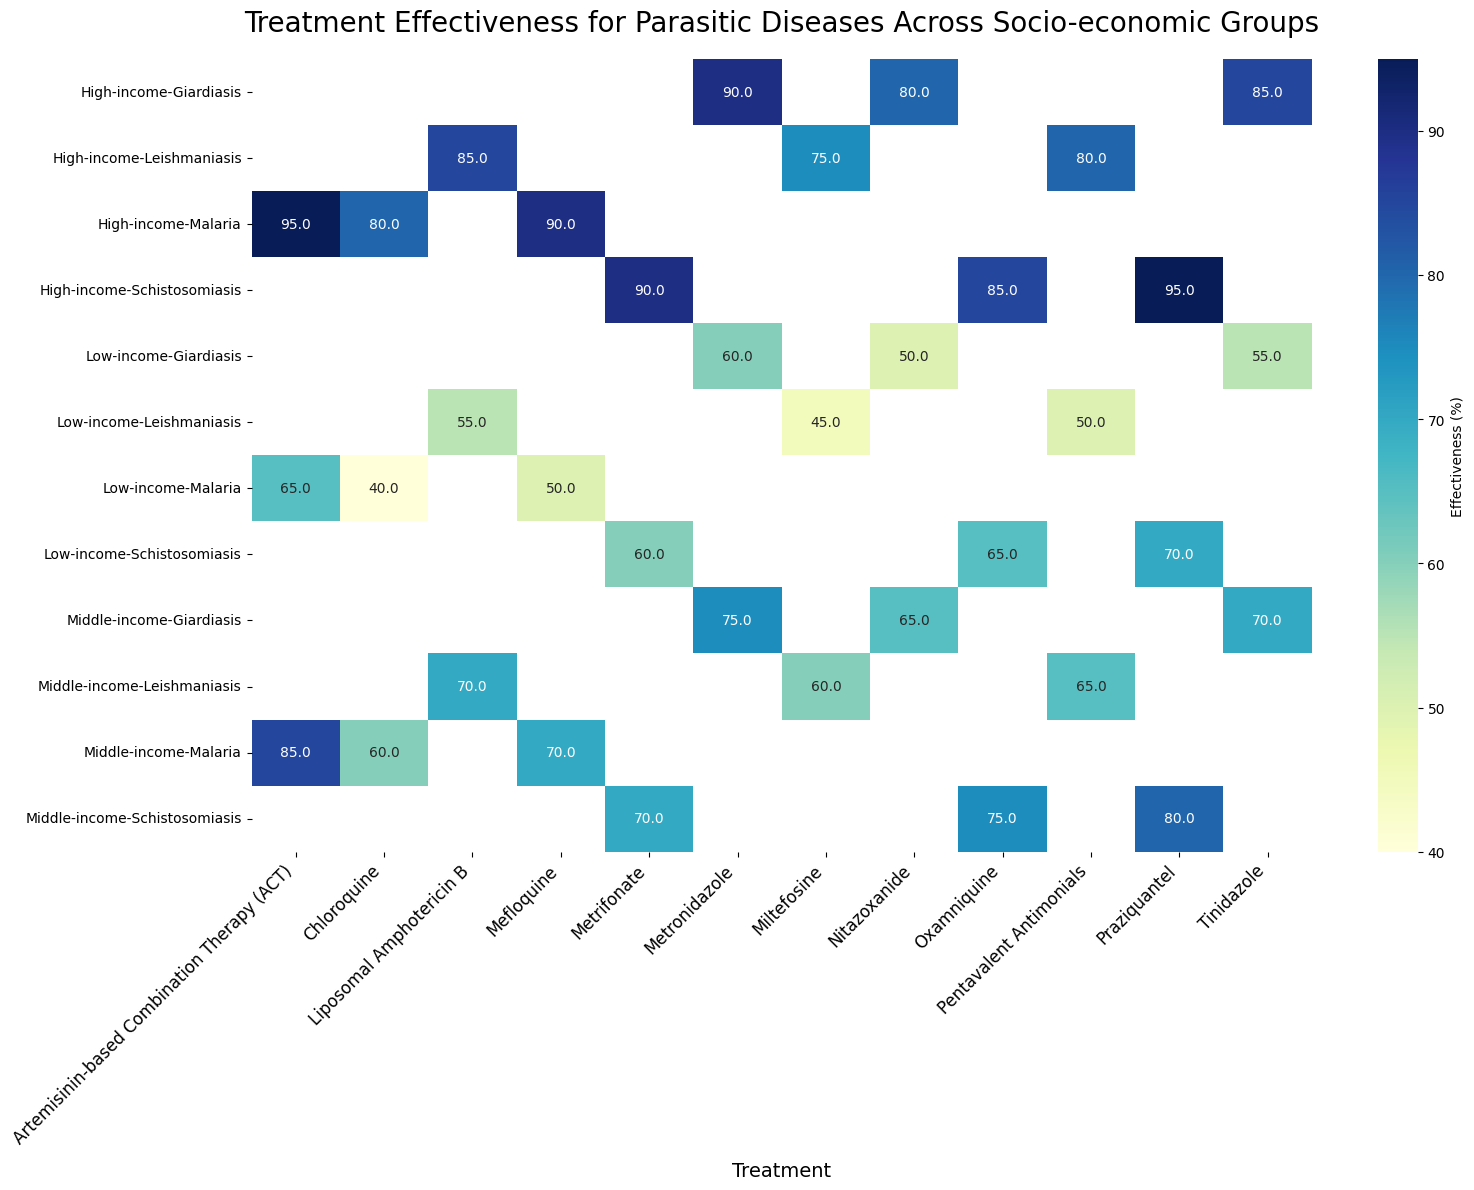Which socio-economic group has the highest treatment effectiveness for Malaria with Artemisinin-based Combination Therapy (ACT)? To find this, locate the rows for each socio-economic group under Malaria and identify the values for Artemisinin-based Combination Therapy (ACT). Compare the values 65%, 85%, and 95%. The highest value is 95% for the High-income group.
Answer: High-income Which treatment shows the least effectiveness for Giardiasis in Low-income groups? Look at the Giardiasis row under the Low-income socio-economic group, and compare the effectiveness values of the treatments: Metronidazole (60%), Tinidazole (55%), and Nitazoxanide (50%). The least effective treatment is Nitazoxanide (50%).
Answer: Nitazoxanide What is the average effectiveness of Praziquantel for treating Schistosomiasis across all socio-economic groups? Identify the effectiveness values for Praziquantel in each socio-economic group: 70% (Low-income), 80% (Middle-income), and 95% (High-income). Calculate the average: (70 + 80 + 95) / 3 = 81.67%.
Answer: 81.67% Which treatment for Leishmaniasis has the smallest range of effectiveness between the socio-economic groups? Find the effectiveness for each treatment across the socio-economic groups: Liposomal Amphotericin B (55%, 70%, 85%), Pentavalent Antimonials (50%, 65%, 80%), Miltefosine (45%, 60%, 75%). Calculate the range (max - min) for each treatment: Liposomal Amphotericin B (85 - 55 = 30), Pentavalent Antimonials (80 - 50 = 30), Miltefosine (75 - 45 = 30). All treatments have the same range (30).
Answer: All treatments have the same range (30) Between Chloroquine and Artemisinin-based Combination Therapy (ACT) for Malaria, which treatment shows greater improvement in effectiveness when comparing Low-income to High-income groups? Calculate the difference in effectiveness between Low-income and High-income for both treatments: Chloroquine (80 - 40 = 40), Artemisinin-based Combination Therapy (ACT) (95 - 65 = 30). Chloroquine shows a greater improvement.
Answer: Chloroquine How does treatment effectiveness for Mefloquine in High-income groups compare to the overall effectiveness of Mefloquine across all socio-economic groups for Malaria? Identify effectiveness values for Mefloquine in each socio-economic group: 50% (Low-income), 70% (Middle-income), 90% (High-income). Calculate the overall effectiveness: (50 + 70 + 90) / 3 = 70%. The effectiveness in High-income groups (90%) is higher than the overall effectiveness (70%).
Answer: Higher (90% vs 70%) What is the difference in effectiveness between the most and least effective treatments for Schistosomiasis in High-income groups? Identify the effectiveness values for each treatment in the High-income group: Praziquantel (95%), Oxamniquine (85%), Metrifonate (90%). The most effective is Praziquantel (95%) and the least effective is Oxamniquine (85%). Calculate the difference: 95 - 85 = 10.
Answer: 10 Which treatment for Giardiasis shows the highest average effectiveness across all socio-economic groups? Calculate the average effectiveness of each treatment across all socio-economic groups: Metronidazole (60%, 75%, 90%) = (60 + 75 + 90) / 3 = 75%, Tinidazole (55%, 70%, 85%) = (55 + 70 + 85) / 3 = 70%, Nitazoxanide (50%, 65%, 80%) = (50 + 65 + 80) / 3 = 65%. Metronidazole has the highest average effectiveness (75%).
Answer: Metronidazole 